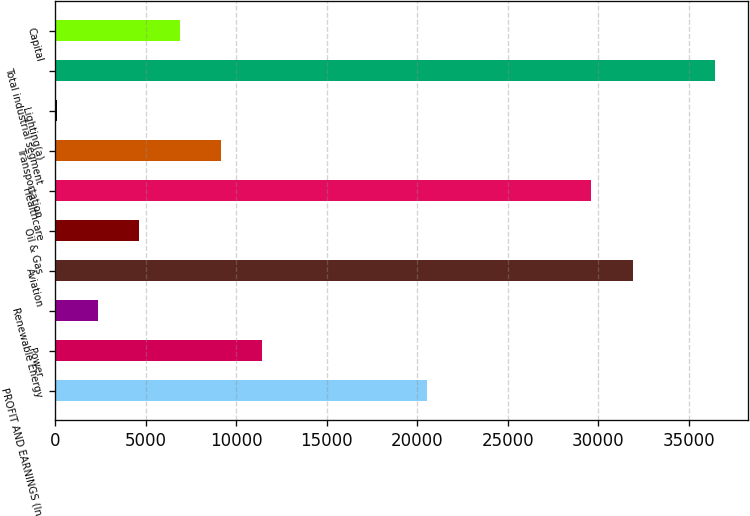<chart> <loc_0><loc_0><loc_500><loc_500><bar_chart><fcel>PROFIT AND EARNINGS (In<fcel>Power<fcel>Renewable Energy<fcel>Aviation<fcel>Oil & Gas<fcel>Healthcare<fcel>Transportation<fcel>Lighting(a)<fcel>Total industrial segment<fcel>Capital<nl><fcel>20528.8<fcel>11436<fcel>2343.2<fcel>31894.8<fcel>4616.4<fcel>29621.6<fcel>9162.8<fcel>70<fcel>36441.2<fcel>6889.6<nl></chart> 